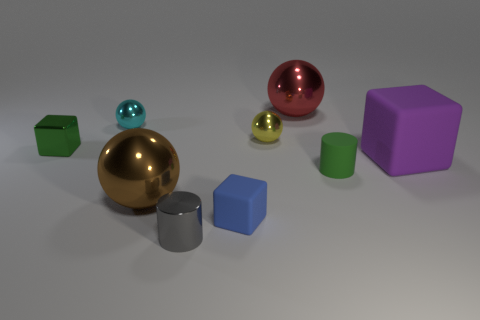Add 1 tiny cyan metallic spheres. How many objects exist? 10 Subtract all blocks. How many objects are left? 6 Add 7 large brown metal things. How many large brown metal things exist? 8 Subtract 0 brown blocks. How many objects are left? 9 Subtract all small green cylinders. Subtract all rubber objects. How many objects are left? 5 Add 6 small metal blocks. How many small metal blocks are left? 7 